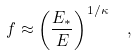<formula> <loc_0><loc_0><loc_500><loc_500>f \approx \left ( \frac { E _ { * } } { E } \right ) ^ { 1 / \kappa } \ \ ,</formula> 